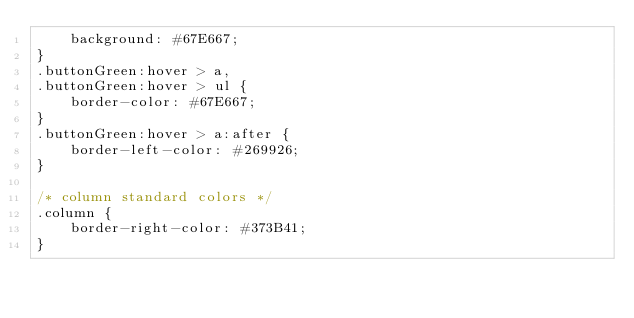Convert code to text. <code><loc_0><loc_0><loc_500><loc_500><_CSS_>    background: #67E667;
}
.buttonGreen:hover > a,
.buttonGreen:hover > ul {
    border-color: #67E667;
}
.buttonGreen:hover > a:after {
    border-left-color: #269926;
}

/* column standard colors */
.column {
    border-right-color: #373B41;
}</code> 